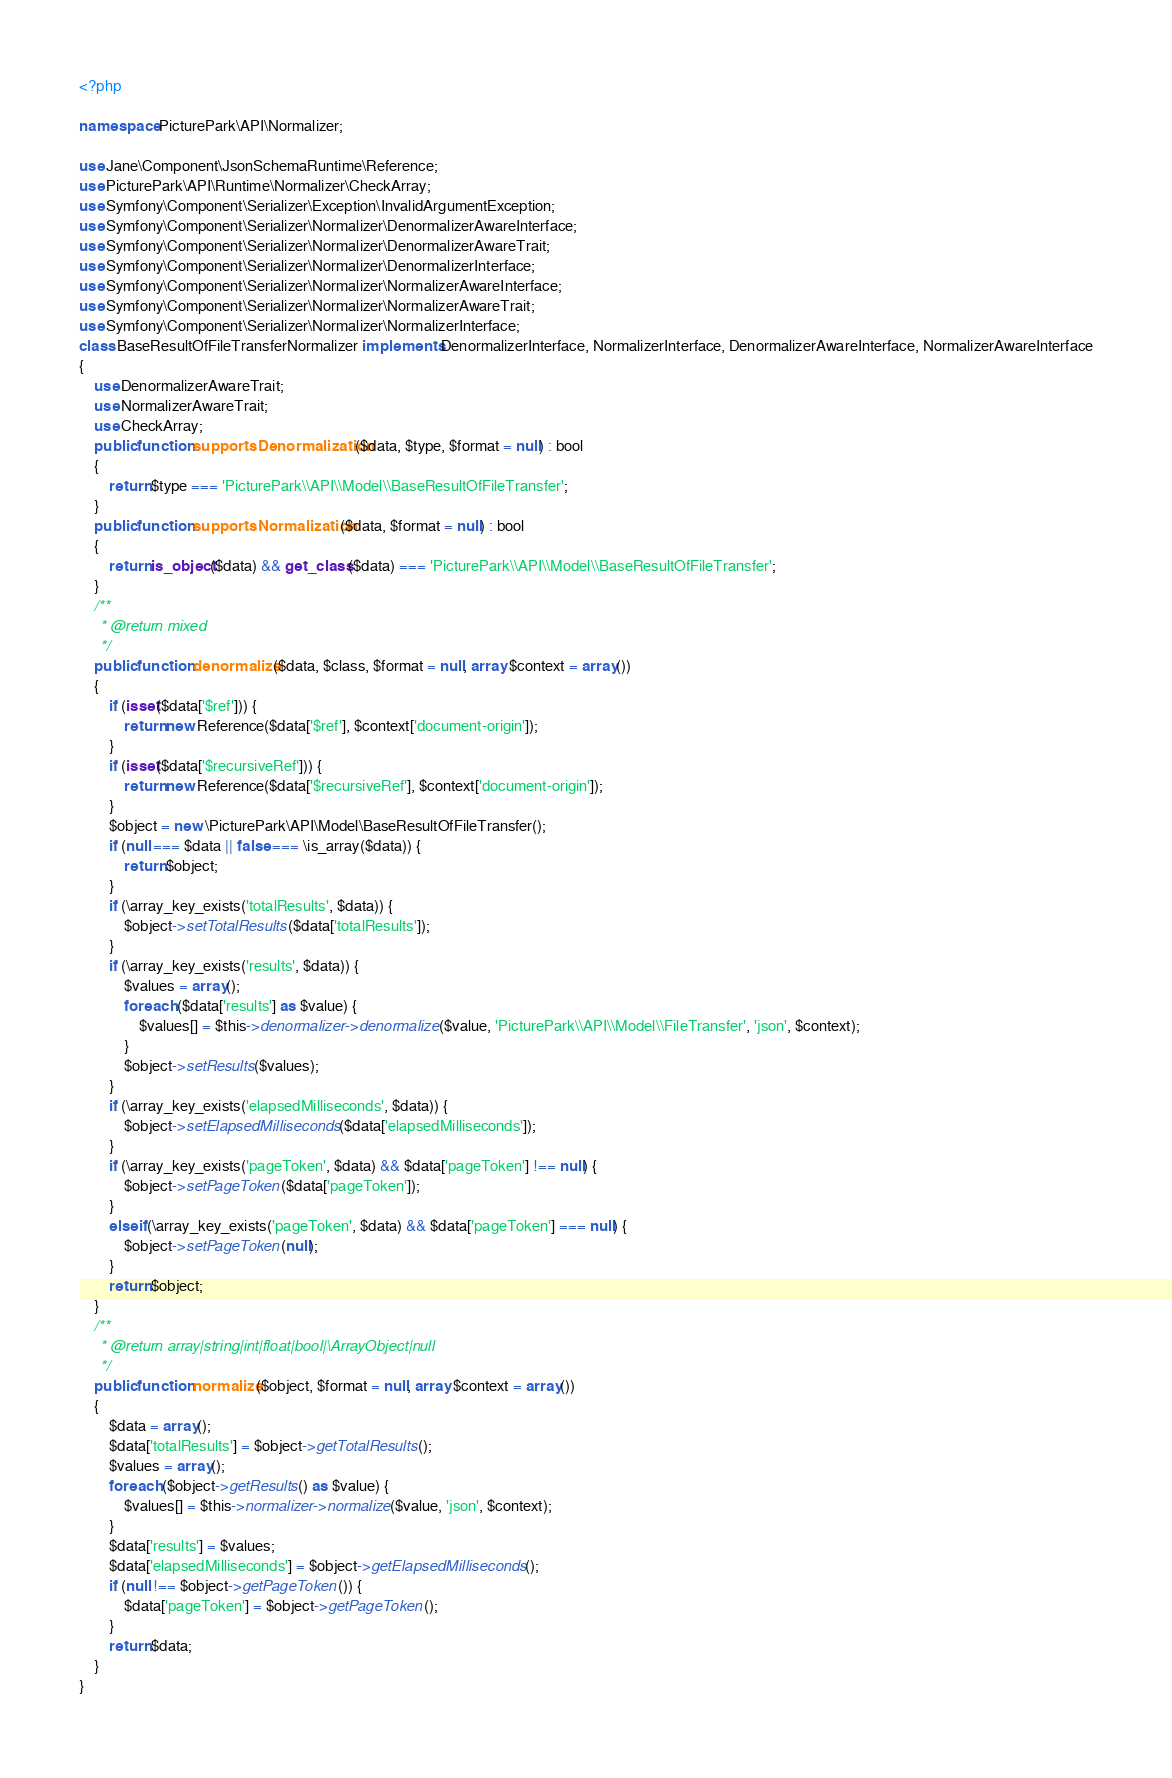<code> <loc_0><loc_0><loc_500><loc_500><_PHP_><?php

namespace PicturePark\API\Normalizer;

use Jane\Component\JsonSchemaRuntime\Reference;
use PicturePark\API\Runtime\Normalizer\CheckArray;
use Symfony\Component\Serializer\Exception\InvalidArgumentException;
use Symfony\Component\Serializer\Normalizer\DenormalizerAwareInterface;
use Symfony\Component\Serializer\Normalizer\DenormalizerAwareTrait;
use Symfony\Component\Serializer\Normalizer\DenormalizerInterface;
use Symfony\Component\Serializer\Normalizer\NormalizerAwareInterface;
use Symfony\Component\Serializer\Normalizer\NormalizerAwareTrait;
use Symfony\Component\Serializer\Normalizer\NormalizerInterface;
class BaseResultOfFileTransferNormalizer implements DenormalizerInterface, NormalizerInterface, DenormalizerAwareInterface, NormalizerAwareInterface
{
    use DenormalizerAwareTrait;
    use NormalizerAwareTrait;
    use CheckArray;
    public function supportsDenormalization($data, $type, $format = null) : bool
    {
        return $type === 'PicturePark\\API\\Model\\BaseResultOfFileTransfer';
    }
    public function supportsNormalization($data, $format = null) : bool
    {
        return is_object($data) && get_class($data) === 'PicturePark\\API\\Model\\BaseResultOfFileTransfer';
    }
    /**
     * @return mixed
     */
    public function denormalize($data, $class, $format = null, array $context = array())
    {
        if (isset($data['$ref'])) {
            return new Reference($data['$ref'], $context['document-origin']);
        }
        if (isset($data['$recursiveRef'])) {
            return new Reference($data['$recursiveRef'], $context['document-origin']);
        }
        $object = new \PicturePark\API\Model\BaseResultOfFileTransfer();
        if (null === $data || false === \is_array($data)) {
            return $object;
        }
        if (\array_key_exists('totalResults', $data)) {
            $object->setTotalResults($data['totalResults']);
        }
        if (\array_key_exists('results', $data)) {
            $values = array();
            foreach ($data['results'] as $value) {
                $values[] = $this->denormalizer->denormalize($value, 'PicturePark\\API\\Model\\FileTransfer', 'json', $context);
            }
            $object->setResults($values);
        }
        if (\array_key_exists('elapsedMilliseconds', $data)) {
            $object->setElapsedMilliseconds($data['elapsedMilliseconds']);
        }
        if (\array_key_exists('pageToken', $data) && $data['pageToken'] !== null) {
            $object->setPageToken($data['pageToken']);
        }
        elseif (\array_key_exists('pageToken', $data) && $data['pageToken'] === null) {
            $object->setPageToken(null);
        }
        return $object;
    }
    /**
     * @return array|string|int|float|bool|\ArrayObject|null
     */
    public function normalize($object, $format = null, array $context = array())
    {
        $data = array();
        $data['totalResults'] = $object->getTotalResults();
        $values = array();
        foreach ($object->getResults() as $value) {
            $values[] = $this->normalizer->normalize($value, 'json', $context);
        }
        $data['results'] = $values;
        $data['elapsedMilliseconds'] = $object->getElapsedMilliseconds();
        if (null !== $object->getPageToken()) {
            $data['pageToken'] = $object->getPageToken();
        }
        return $data;
    }
}</code> 